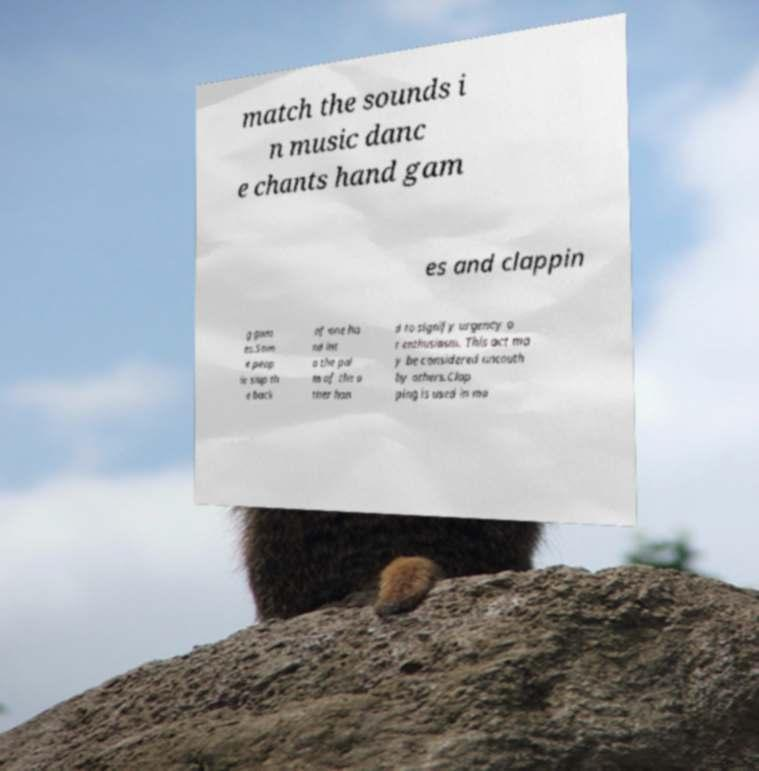Could you assist in decoding the text presented in this image and type it out clearly? match the sounds i n music danc e chants hand gam es and clappin g gam es.Som e peop le slap th e back of one ha nd int o the pal m of the o ther han d to signify urgency o r enthusiasm. This act ma y be considered uncouth by others.Clap ping is used in ma 